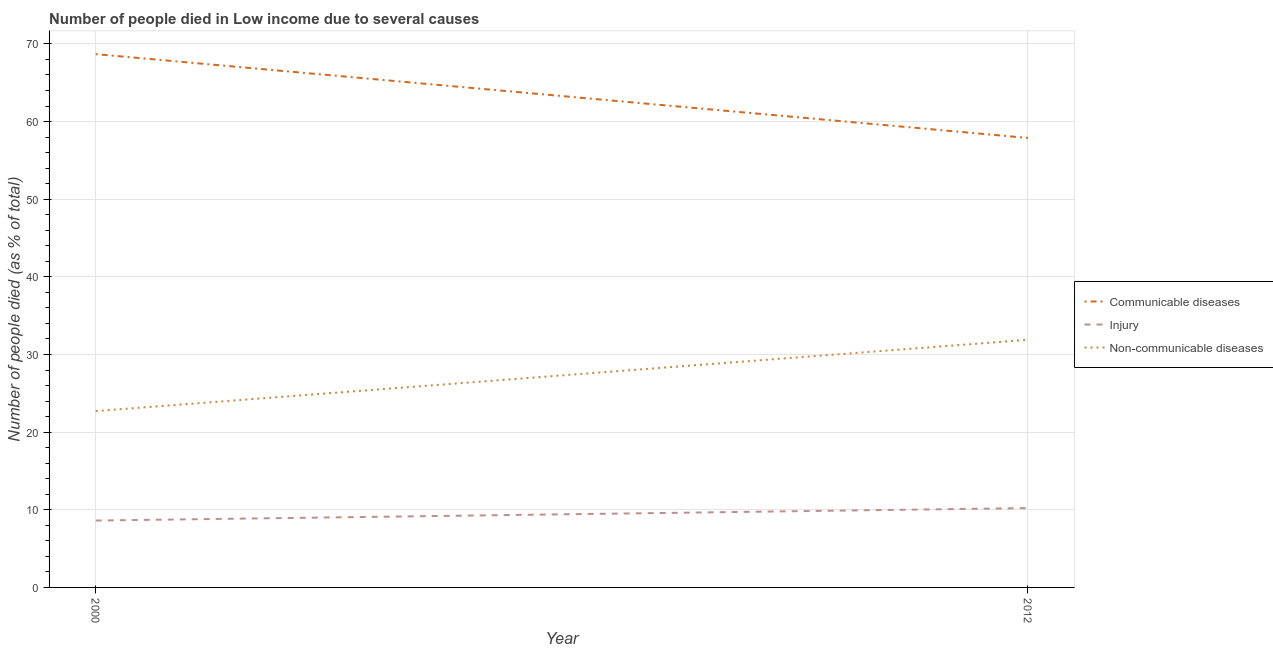How many different coloured lines are there?
Ensure brevity in your answer.  3. Does the line corresponding to number of people who dies of non-communicable diseases intersect with the line corresponding to number of people who died of communicable diseases?
Offer a terse response. No. What is the number of people who died of injury in 2012?
Give a very brief answer. 10.22. Across all years, what is the maximum number of people who died of injury?
Provide a short and direct response. 10.22. Across all years, what is the minimum number of people who dies of non-communicable diseases?
Keep it short and to the point. 22.71. In which year was the number of people who died of communicable diseases minimum?
Your response must be concise. 2012. What is the total number of people who died of communicable diseases in the graph?
Keep it short and to the point. 126.57. What is the difference between the number of people who died of communicable diseases in 2000 and that in 2012?
Keep it short and to the point. 10.79. What is the difference between the number of people who dies of non-communicable diseases in 2012 and the number of people who died of injury in 2000?
Provide a succinct answer. 23.28. What is the average number of people who died of communicable diseases per year?
Your answer should be compact. 63.28. In the year 2000, what is the difference between the number of people who died of injury and number of people who dies of non-communicable diseases?
Offer a very short reply. -14.1. What is the ratio of the number of people who dies of non-communicable diseases in 2000 to that in 2012?
Your answer should be very brief. 0.71. In how many years, is the number of people who died of injury greater than the average number of people who died of injury taken over all years?
Keep it short and to the point. 1. Does the number of people who died of communicable diseases monotonically increase over the years?
Provide a succinct answer. No. Is the number of people who died of injury strictly less than the number of people who dies of non-communicable diseases over the years?
Your answer should be compact. Yes. How many legend labels are there?
Give a very brief answer. 3. What is the title of the graph?
Give a very brief answer. Number of people died in Low income due to several causes. What is the label or title of the X-axis?
Give a very brief answer. Year. What is the label or title of the Y-axis?
Keep it short and to the point. Number of people died (as % of total). What is the Number of people died (as % of total) in Communicable diseases in 2000?
Make the answer very short. 68.68. What is the Number of people died (as % of total) in Injury in 2000?
Provide a short and direct response. 8.61. What is the Number of people died (as % of total) of Non-communicable diseases in 2000?
Your answer should be very brief. 22.71. What is the Number of people died (as % of total) in Communicable diseases in 2012?
Your answer should be compact. 57.89. What is the Number of people died (as % of total) of Injury in 2012?
Your answer should be very brief. 10.22. What is the Number of people died (as % of total) of Non-communicable diseases in 2012?
Provide a short and direct response. 31.89. Across all years, what is the maximum Number of people died (as % of total) in Communicable diseases?
Ensure brevity in your answer.  68.68. Across all years, what is the maximum Number of people died (as % of total) in Injury?
Your answer should be very brief. 10.22. Across all years, what is the maximum Number of people died (as % of total) of Non-communicable diseases?
Provide a short and direct response. 31.89. Across all years, what is the minimum Number of people died (as % of total) of Communicable diseases?
Your answer should be compact. 57.89. Across all years, what is the minimum Number of people died (as % of total) in Injury?
Your answer should be compact. 8.61. Across all years, what is the minimum Number of people died (as % of total) of Non-communicable diseases?
Your answer should be compact. 22.71. What is the total Number of people died (as % of total) in Communicable diseases in the graph?
Your answer should be very brief. 126.57. What is the total Number of people died (as % of total) in Injury in the graph?
Give a very brief answer. 18.83. What is the total Number of people died (as % of total) of Non-communicable diseases in the graph?
Offer a terse response. 54.61. What is the difference between the Number of people died (as % of total) of Communicable diseases in 2000 and that in 2012?
Provide a succinct answer. 10.79. What is the difference between the Number of people died (as % of total) in Injury in 2000 and that in 2012?
Make the answer very short. -1.61. What is the difference between the Number of people died (as % of total) in Non-communicable diseases in 2000 and that in 2012?
Your answer should be compact. -9.18. What is the difference between the Number of people died (as % of total) in Communicable diseases in 2000 and the Number of people died (as % of total) in Injury in 2012?
Provide a short and direct response. 58.46. What is the difference between the Number of people died (as % of total) in Communicable diseases in 2000 and the Number of people died (as % of total) in Non-communicable diseases in 2012?
Offer a terse response. 36.79. What is the difference between the Number of people died (as % of total) of Injury in 2000 and the Number of people died (as % of total) of Non-communicable diseases in 2012?
Offer a very short reply. -23.28. What is the average Number of people died (as % of total) in Communicable diseases per year?
Provide a succinct answer. 63.28. What is the average Number of people died (as % of total) in Injury per year?
Make the answer very short. 9.41. What is the average Number of people died (as % of total) in Non-communicable diseases per year?
Offer a terse response. 27.3. In the year 2000, what is the difference between the Number of people died (as % of total) of Communicable diseases and Number of people died (as % of total) of Injury?
Ensure brevity in your answer.  60.07. In the year 2000, what is the difference between the Number of people died (as % of total) in Communicable diseases and Number of people died (as % of total) in Non-communicable diseases?
Make the answer very short. 45.97. In the year 2000, what is the difference between the Number of people died (as % of total) in Injury and Number of people died (as % of total) in Non-communicable diseases?
Ensure brevity in your answer.  -14.1. In the year 2012, what is the difference between the Number of people died (as % of total) in Communicable diseases and Number of people died (as % of total) in Injury?
Provide a short and direct response. 47.67. In the year 2012, what is the difference between the Number of people died (as % of total) of Communicable diseases and Number of people died (as % of total) of Non-communicable diseases?
Your answer should be compact. 26. In the year 2012, what is the difference between the Number of people died (as % of total) of Injury and Number of people died (as % of total) of Non-communicable diseases?
Give a very brief answer. -21.68. What is the ratio of the Number of people died (as % of total) in Communicable diseases in 2000 to that in 2012?
Keep it short and to the point. 1.19. What is the ratio of the Number of people died (as % of total) in Injury in 2000 to that in 2012?
Offer a terse response. 0.84. What is the ratio of the Number of people died (as % of total) in Non-communicable diseases in 2000 to that in 2012?
Make the answer very short. 0.71. What is the difference between the highest and the second highest Number of people died (as % of total) in Communicable diseases?
Make the answer very short. 10.79. What is the difference between the highest and the second highest Number of people died (as % of total) of Injury?
Your answer should be very brief. 1.61. What is the difference between the highest and the second highest Number of people died (as % of total) of Non-communicable diseases?
Make the answer very short. 9.18. What is the difference between the highest and the lowest Number of people died (as % of total) in Communicable diseases?
Your answer should be compact. 10.79. What is the difference between the highest and the lowest Number of people died (as % of total) in Injury?
Your answer should be very brief. 1.61. What is the difference between the highest and the lowest Number of people died (as % of total) of Non-communicable diseases?
Your answer should be very brief. 9.18. 